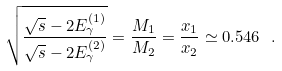<formula> <loc_0><loc_0><loc_500><loc_500>\sqrt { \frac { \sqrt { s } - 2 E _ { \gamma } ^ { ( 1 ) } } { \sqrt { s } - 2 E _ { \gamma } ^ { ( 2 ) } } } = \frac { M _ { 1 } } { M _ { 2 } } = \frac { x _ { 1 } } { x _ { 2 } } \simeq 0 . 5 4 6 \ .</formula> 